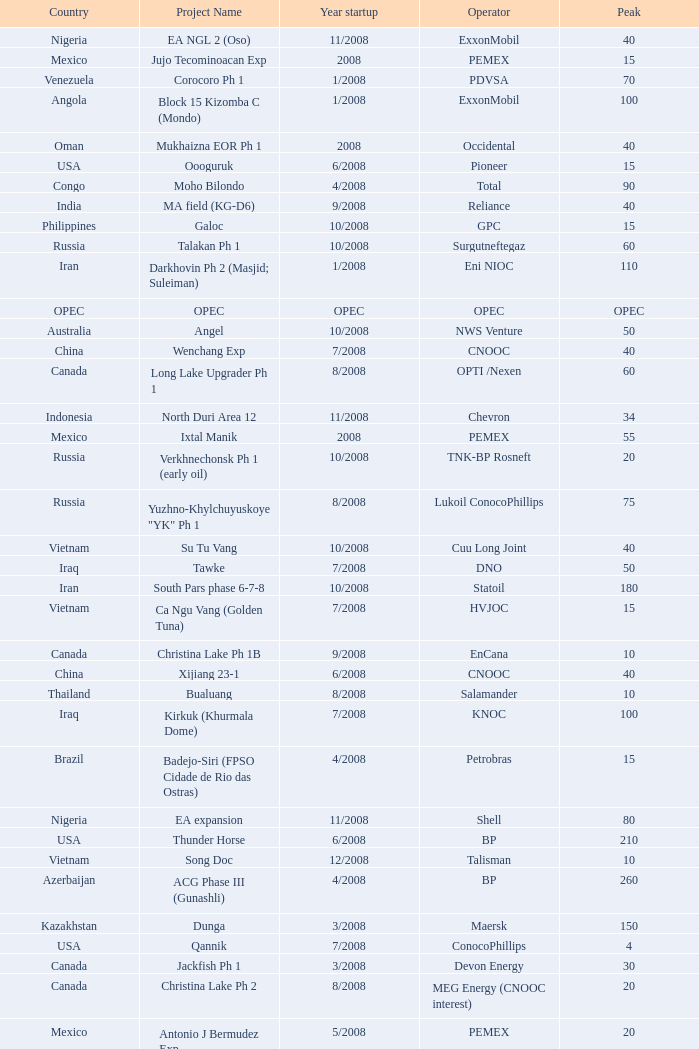What is the Project Name with a Country that is kazakhstan and a Peak that is 150? Dunga. 